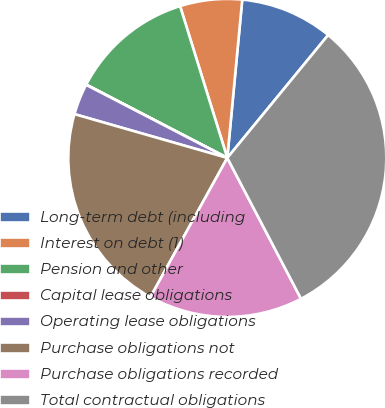Convert chart to OTSL. <chart><loc_0><loc_0><loc_500><loc_500><pie_chart><fcel>Long-term debt (including<fcel>Interest on debt (1)<fcel>Pension and other<fcel>Capital lease obligations<fcel>Operating lease obligations<fcel>Purchase obligations not<fcel>Purchase obligations recorded<fcel>Total contractual obligations<nl><fcel>9.44%<fcel>6.3%<fcel>12.57%<fcel>0.03%<fcel>3.16%<fcel>21.41%<fcel>15.71%<fcel>31.39%<nl></chart> 